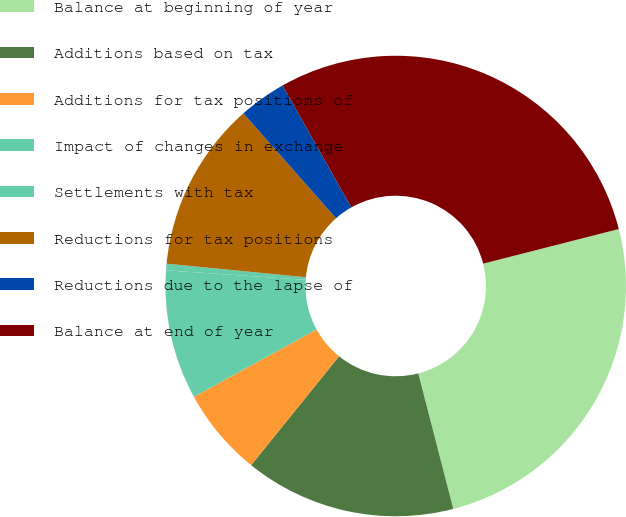Convert chart to OTSL. <chart><loc_0><loc_0><loc_500><loc_500><pie_chart><fcel>Balance at beginning of year<fcel>Additions based on tax<fcel>Additions for tax positions of<fcel>Impact of changes in exchange<fcel>Settlements with tax<fcel>Reductions for tax positions<fcel>Reductions due to the lapse of<fcel>Balance at end of year<nl><fcel>24.96%<fcel>14.83%<fcel>6.2%<fcel>9.08%<fcel>0.46%<fcel>11.95%<fcel>3.33%<fcel>29.2%<nl></chart> 